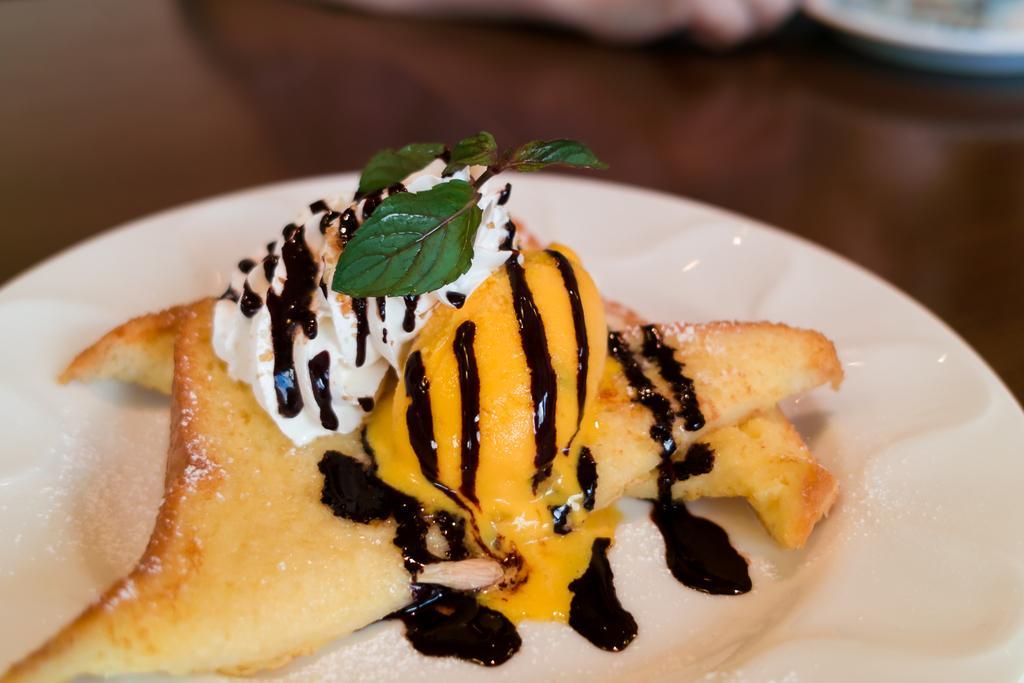Please provide a concise description of this image. In this image we can see a plate of food item and the plate is placed on the wooden table. We can also see some person's hand and an object at the top. 